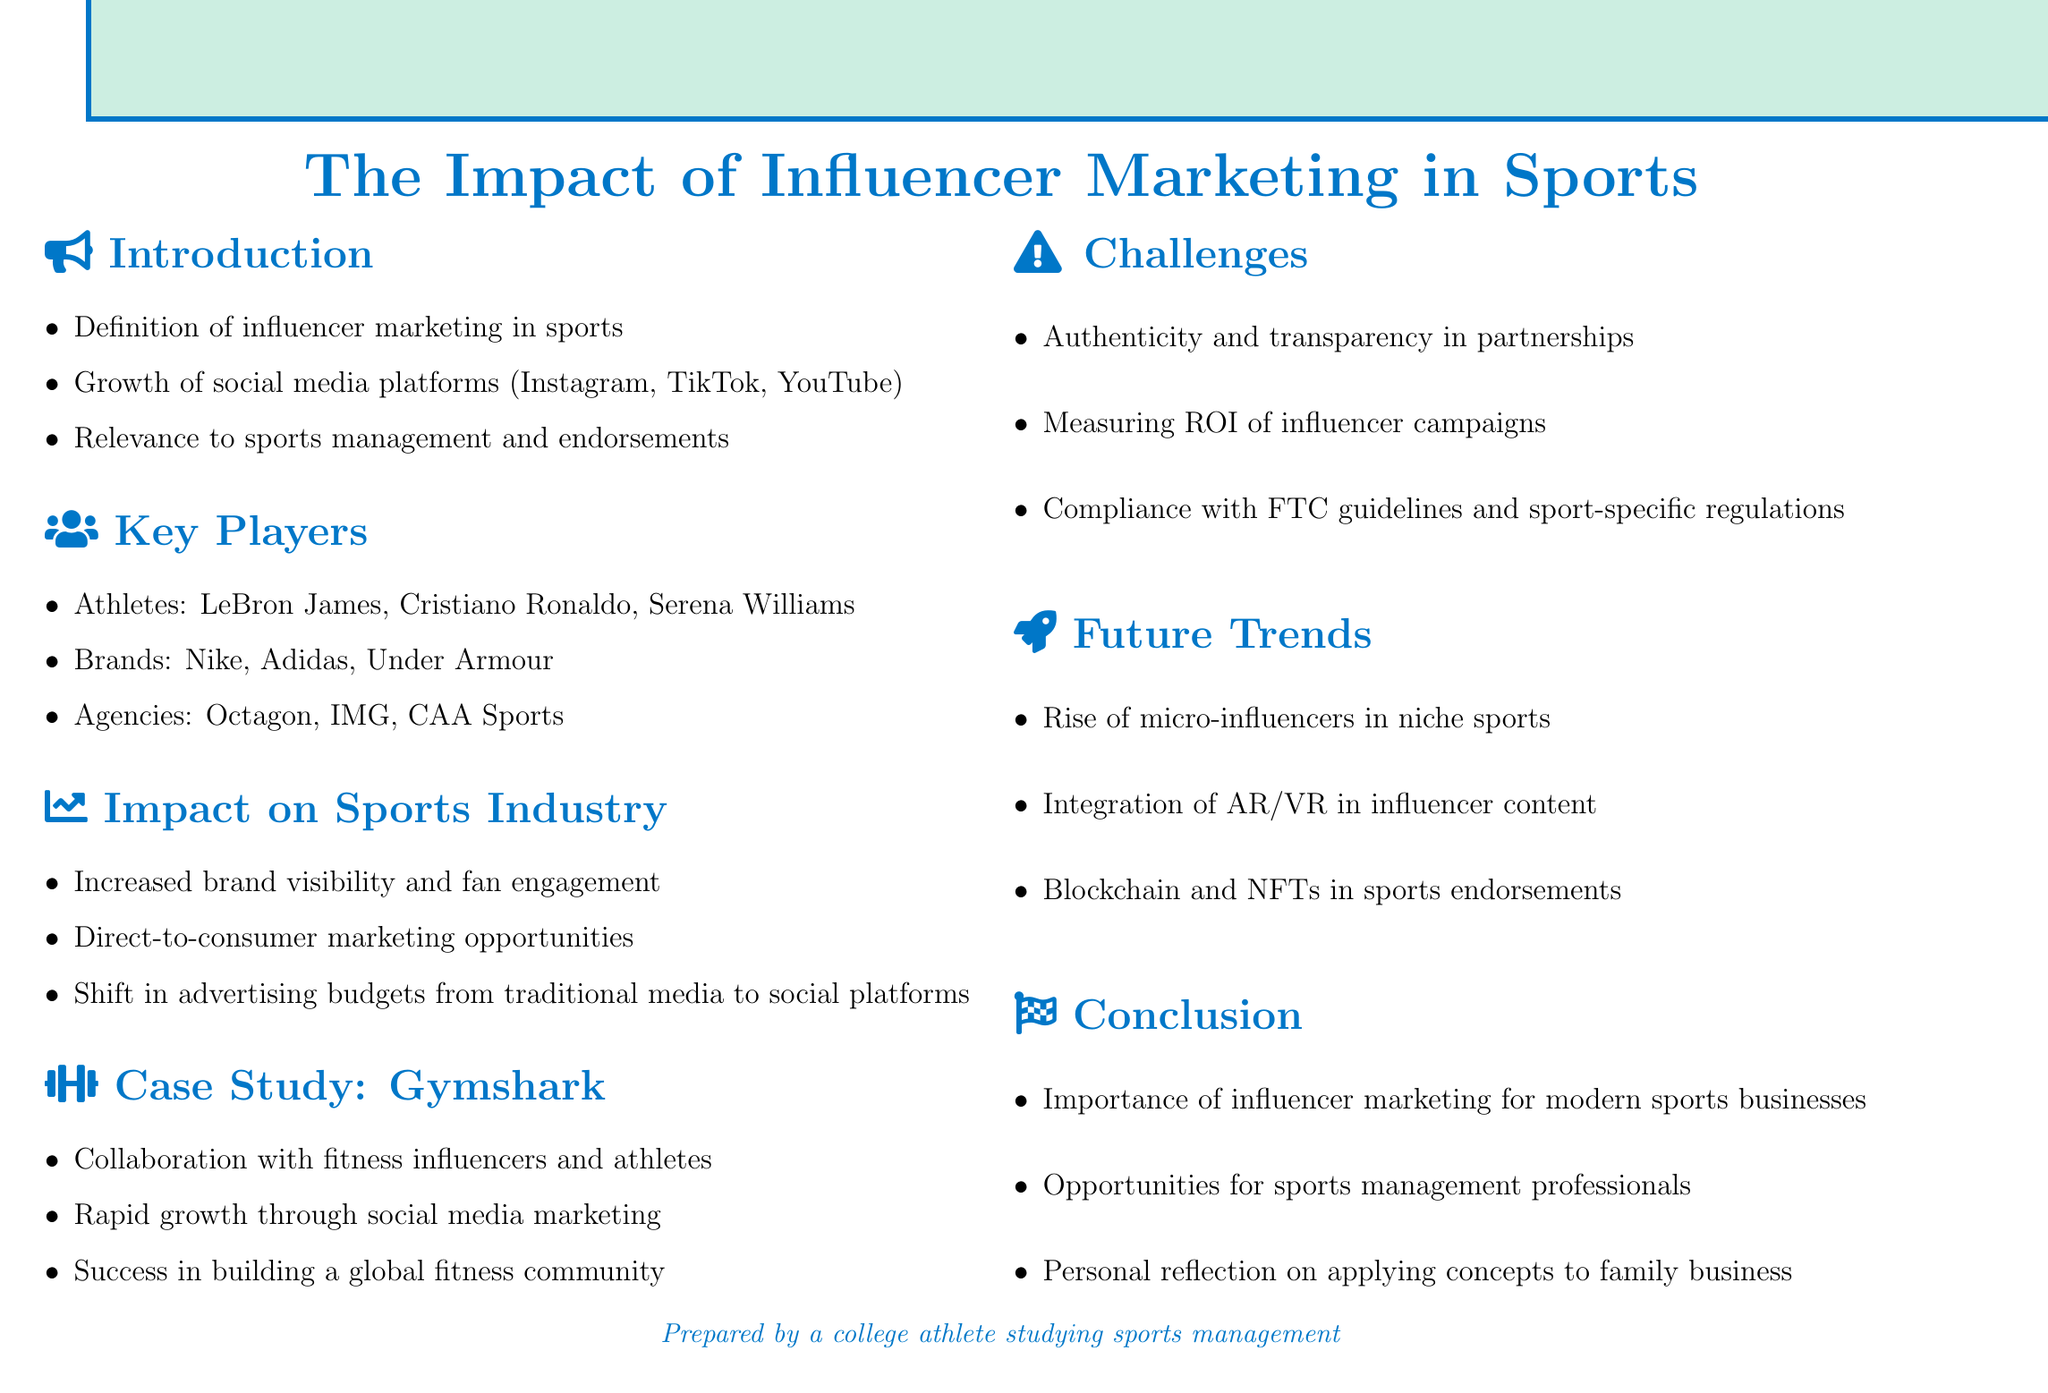What is the title of the document? The title is explicitly stated in the document's heading.
Answer: The Impact of Influencer Marketing in Sports Name one social media platform mentioned in the introduction. The introduction lists social media platforms relevant to the topic.
Answer: Instagram Who is one key player mentioned as an athlete in sports influencer marketing? The "Key Players" section provides examples of athletes involved in the field.
Answer: LeBron James What is one challenge discussed regarding influencer marketing? The "Challenges and Considerations" section identifies issues related to influencer marketing.
Answer: Authenticity What trend is predicted to rise in the future of sports influencer marketing? The "Future Trends" section outlines upcoming developments in the industry.
Answer: Micro-influencers What is one primary impact of influencer marketing on the sports industry? The section on the impact outlines several significant effects of influencer marketing.
Answer: Increased brand visibility and fan engagement What company is used as a case study in the document? The case study section focuses on a specific company's approach to influencer marketing.
Answer: Gymshark Which agency is mentioned in the "Key Players" section? The "Key Players" section names several influential agencies in sports marketing.
Answer: Octagon What does the conclusion suggest about opportunities for professionals? The conclusion discusses the relevance and potential for professionals in the field of sports management.
Answer: Opportunities for sports management professionals 